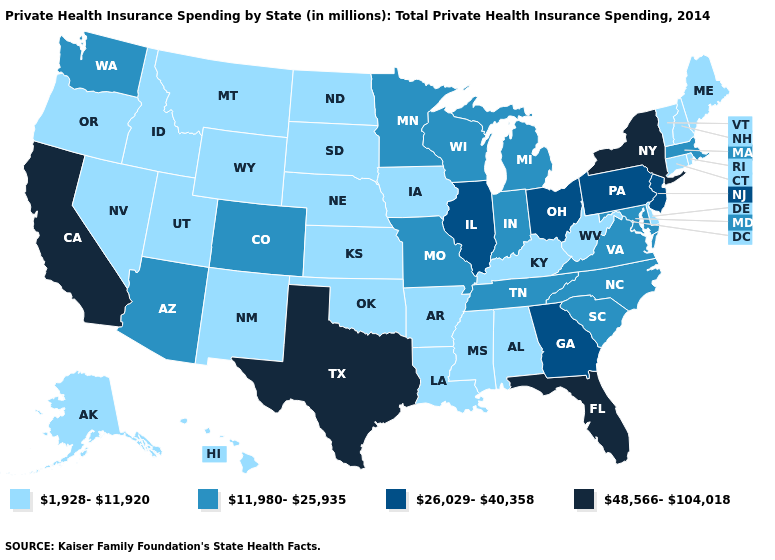What is the lowest value in the MidWest?
Write a very short answer. 1,928-11,920. How many symbols are there in the legend?
Quick response, please. 4. Which states have the lowest value in the West?
Be succinct. Alaska, Hawaii, Idaho, Montana, Nevada, New Mexico, Oregon, Utah, Wyoming. Name the states that have a value in the range 48,566-104,018?
Keep it brief. California, Florida, New York, Texas. What is the highest value in the USA?
Quick response, please. 48,566-104,018. Among the states that border Delaware , does New Jersey have the lowest value?
Give a very brief answer. No. Does Colorado have a higher value than Alaska?
Answer briefly. Yes. Is the legend a continuous bar?
Answer briefly. No. What is the value of Maryland?
Keep it brief. 11,980-25,935. Does the first symbol in the legend represent the smallest category?
Give a very brief answer. Yes. Name the states that have a value in the range 26,029-40,358?
Keep it brief. Georgia, Illinois, New Jersey, Ohio, Pennsylvania. Does Arizona have the lowest value in the USA?
Concise answer only. No. Which states have the lowest value in the USA?
Answer briefly. Alabama, Alaska, Arkansas, Connecticut, Delaware, Hawaii, Idaho, Iowa, Kansas, Kentucky, Louisiana, Maine, Mississippi, Montana, Nebraska, Nevada, New Hampshire, New Mexico, North Dakota, Oklahoma, Oregon, Rhode Island, South Dakota, Utah, Vermont, West Virginia, Wyoming. Among the states that border South Carolina , does North Carolina have the highest value?
Answer briefly. No. What is the lowest value in states that border Ohio?
Concise answer only. 1,928-11,920. 